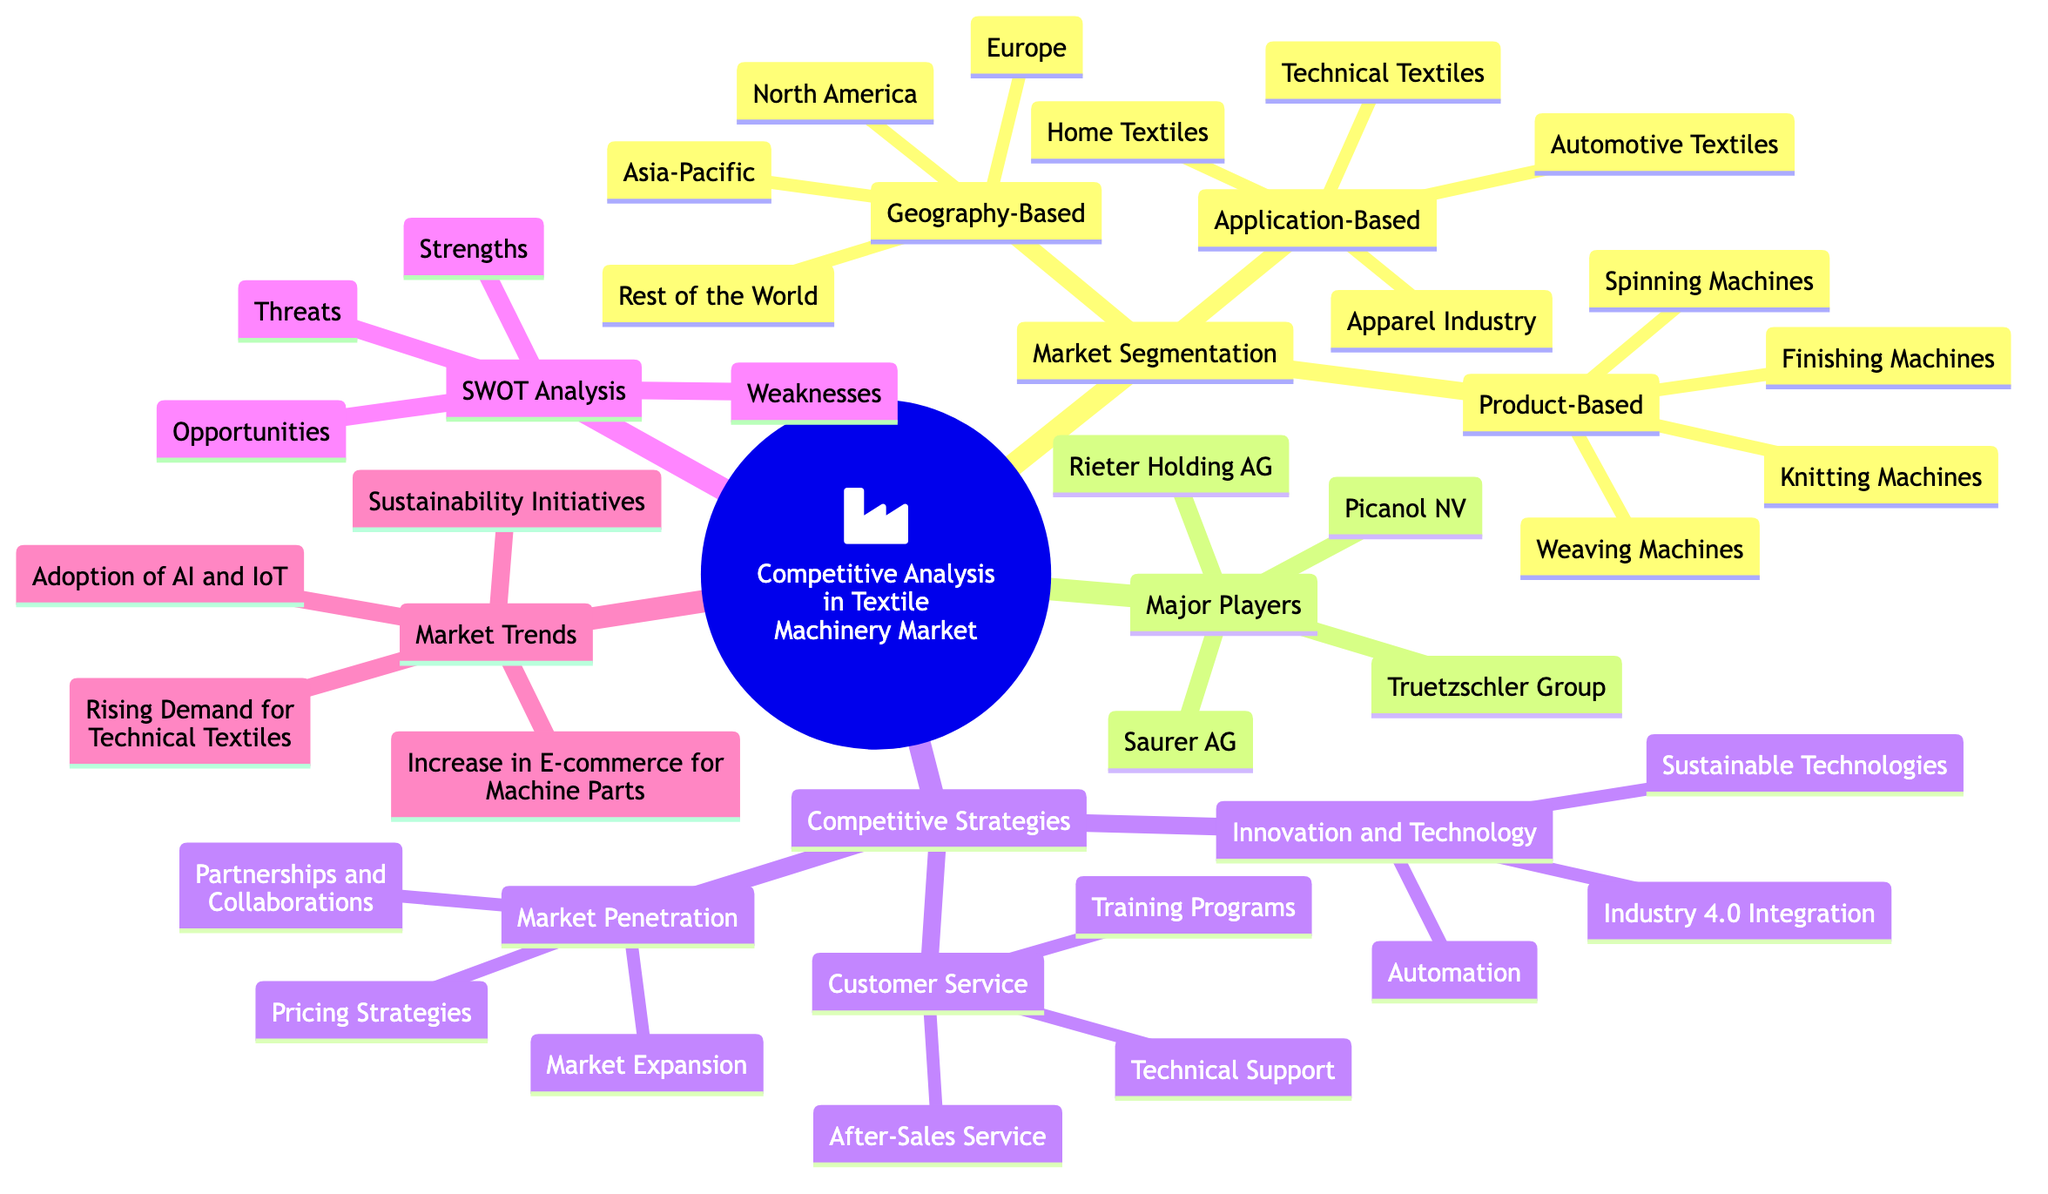What are the main branches of the mind map? The main branches of the mind map are Market Segmentation, Major Players, Competitive Strategies, SWOT Analysis, and Market Trends. Each main branch represents a unique aspect of Competitive Analysis in the Textile Machinery Market.
Answer: Market Segmentation, Major Players, Competitive Strategies, SWOT Analysis, Market Trends How many sub-branches does Market Segmentation have? Market Segmentation has three sub-branches: Geography-Based, Product-Based, and Application-Based. This categorizes the market segmentation into distinct areas of focus.
Answer: 3 Which major player is listed first? Truetzschler Group is the first major player listed in the Major Players section of the mind map, indicating it might be a significant company in the market.
Answer: Truetzschler Group What competitive strategy focuses on technological advancements? Innovation and Technology is the competitive strategy that focuses on technological advancements, including aspects such as automation and sustainable technologies.
Answer: Innovation and Technology In which market trend is there an increase noted specifically for machine parts? The trend "Increase in E-commerce for Machine Parts" indicates that there is a noted increase in this area, highlighting growth in online transactions for machine components.
Answer: Increase in E-commerce for Machine Parts Which application-based segment is mentioned as part of the analysis? The application-based segments included are Apparel Industry, Home Textiles, Technical Textiles, and Automotive Textiles, showcasing various sectors utilizing textile machinery.
Answer: Apparel Industry, Home Textiles, Technical Textiles, Automotive Textiles What type of analysis is performed in the SWOT Analysis branch? The SWOT Analysis branch involves assessing Strengths, Weaknesses, Opportunities, and Threats, which are common components in strategic planning and competitive analysis.
Answer: Strengths, Weaknesses, Opportunities, Threats What competitive strategy involves partnerships and collaborations? Market Penetration includes the strategy of Partnerships and Collaborations, emphasizing the importance of teamwork in expanding market reach.
Answer: Partnerships and Collaborations How many total major players are listed in the diagram? There are four major players listed in the Major Players section: Truetzschler Group, Rieter Holding AG, Saurer AG, and Picanol NV, indicating a competitive landscape.
Answer: 4 